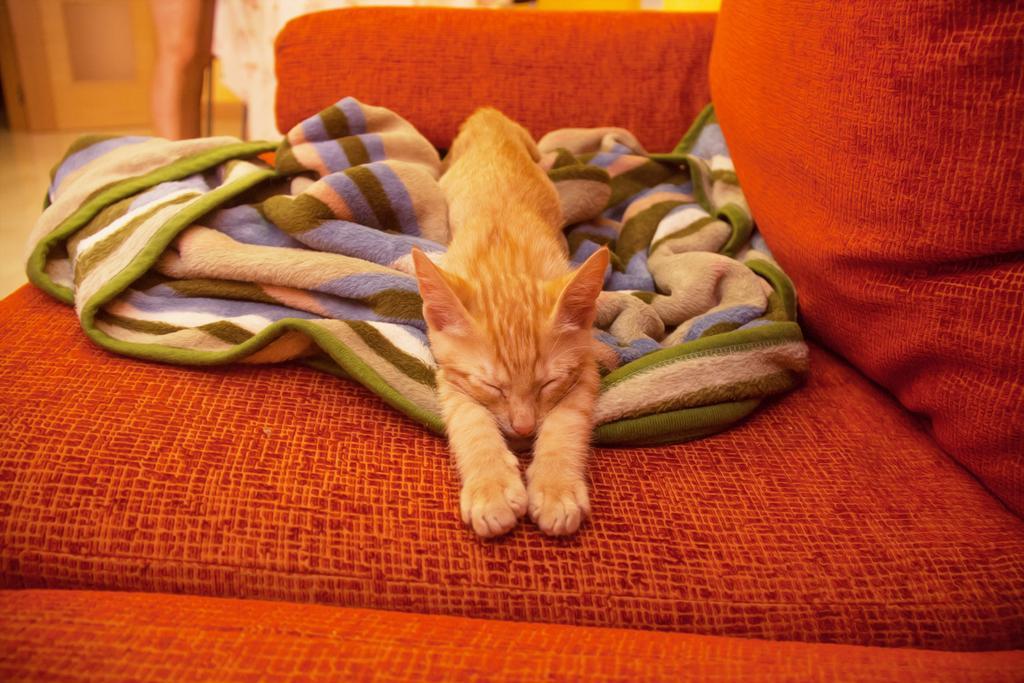How would you summarize this image in a sentence or two? In the image we can see there is a cat which is lying on the sofa and there is a blanket under the cat. The sofa is in orange colour. 